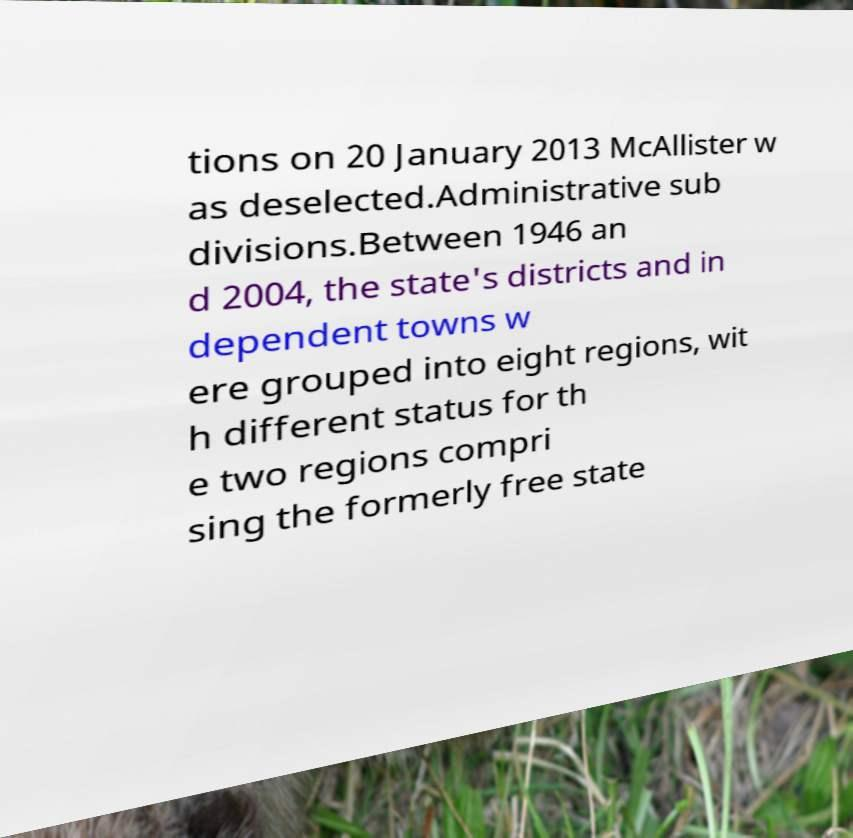Can you read and provide the text displayed in the image?This photo seems to have some interesting text. Can you extract and type it out for me? tions on 20 January 2013 McAllister w as deselected.Administrative sub divisions.Between 1946 an d 2004, the state's districts and in dependent towns w ere grouped into eight regions, wit h different status for th e two regions compri sing the formerly free state 